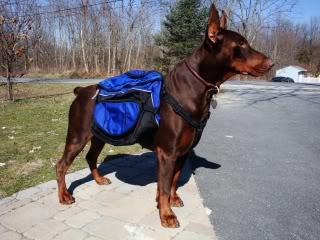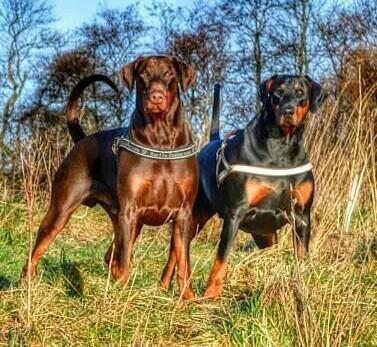The first image is the image on the left, the second image is the image on the right. Given the left and right images, does the statement "There are at least three dogs in total." hold true? Answer yes or no. Yes. The first image is the image on the left, the second image is the image on the right. Evaluate the accuracy of this statement regarding the images: "The right image features two side-by-side forward-facing floppy-eared doberman with collar-like things around their shoulders.". Is it true? Answer yes or no. Yes. 